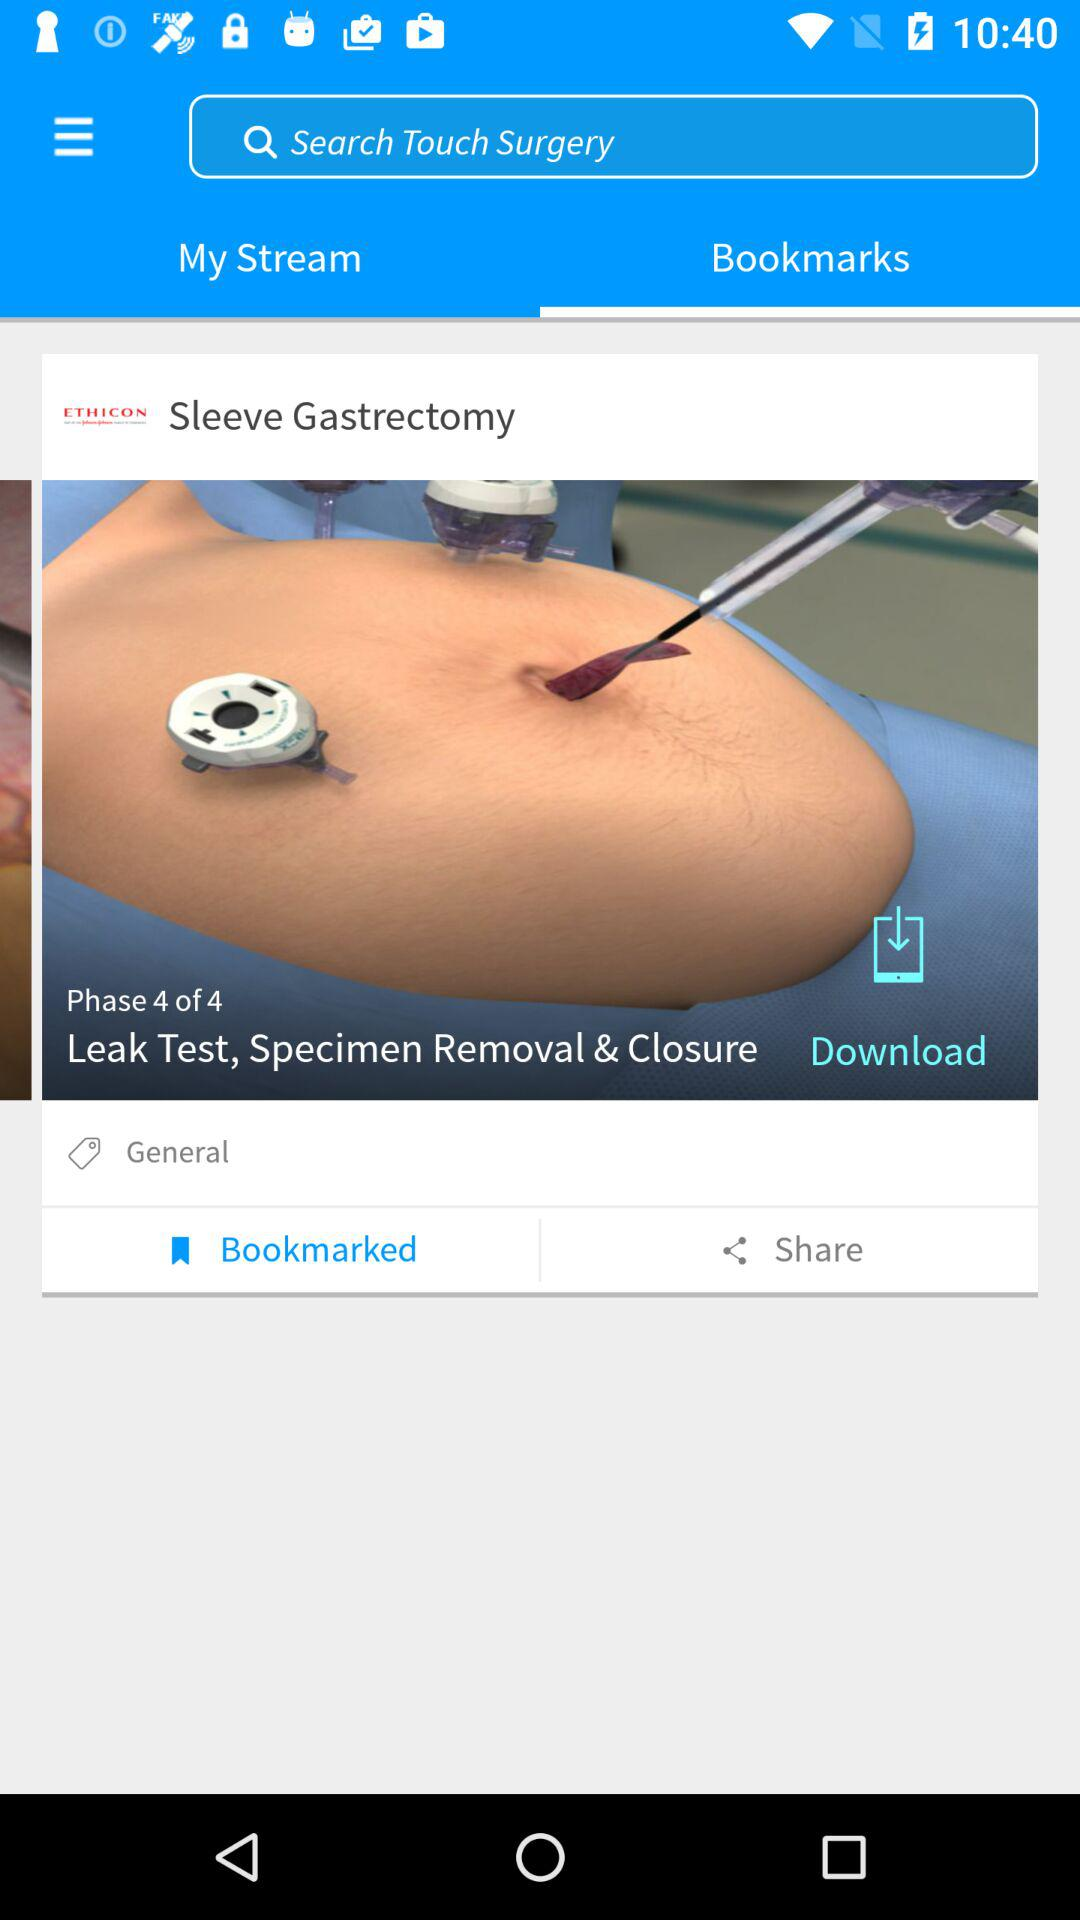On which phase is the person? The person is on the fourth phase. 